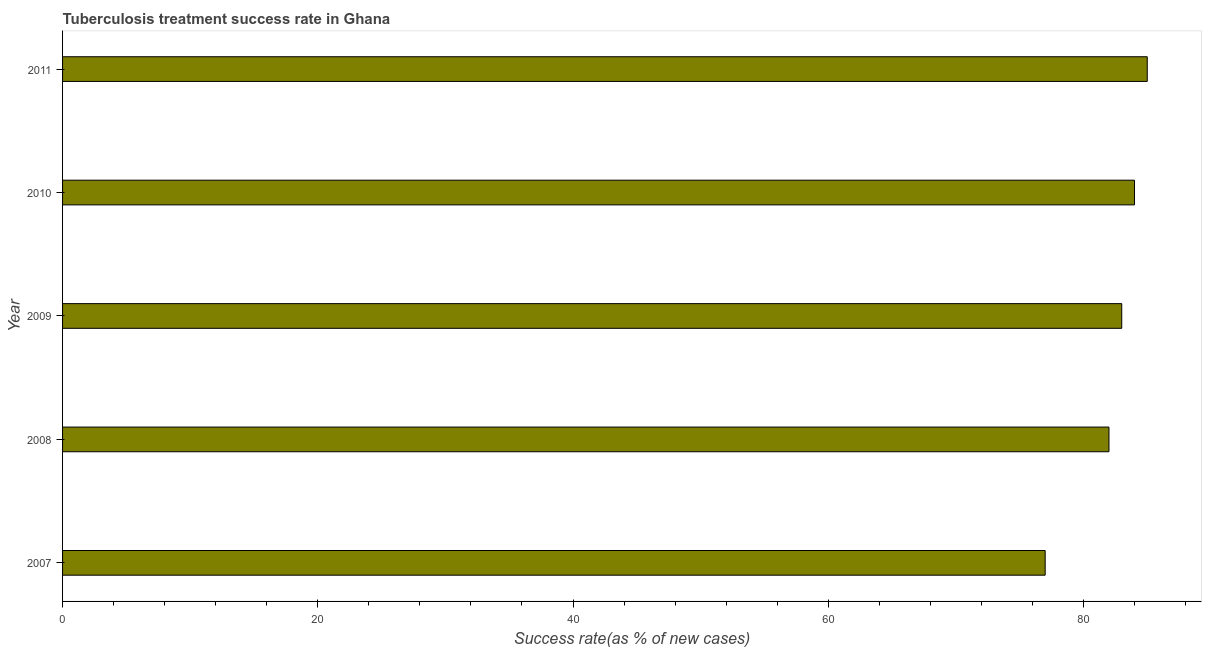Does the graph contain any zero values?
Offer a terse response. No. Does the graph contain grids?
Your answer should be very brief. No. What is the title of the graph?
Provide a short and direct response. Tuberculosis treatment success rate in Ghana. What is the label or title of the X-axis?
Offer a terse response. Success rate(as % of new cases). What is the tuberculosis treatment success rate in 2011?
Offer a very short reply. 85. In which year was the tuberculosis treatment success rate maximum?
Make the answer very short. 2011. What is the sum of the tuberculosis treatment success rate?
Give a very brief answer. 411. What is the difference between the tuberculosis treatment success rate in 2007 and 2009?
Your answer should be very brief. -6. What is the ratio of the tuberculosis treatment success rate in 2007 to that in 2010?
Give a very brief answer. 0.92. Is the difference between the tuberculosis treatment success rate in 2008 and 2011 greater than the difference between any two years?
Your answer should be compact. No. What is the difference between the highest and the second highest tuberculosis treatment success rate?
Your response must be concise. 1. Is the sum of the tuberculosis treatment success rate in 2008 and 2010 greater than the maximum tuberculosis treatment success rate across all years?
Ensure brevity in your answer.  Yes. In how many years, is the tuberculosis treatment success rate greater than the average tuberculosis treatment success rate taken over all years?
Give a very brief answer. 3. How many bars are there?
Offer a terse response. 5. Are all the bars in the graph horizontal?
Provide a short and direct response. Yes. How many years are there in the graph?
Provide a short and direct response. 5. What is the Success rate(as % of new cases) in 2007?
Offer a terse response. 77. What is the difference between the Success rate(as % of new cases) in 2007 and 2009?
Offer a terse response. -6. What is the difference between the Success rate(as % of new cases) in 2007 and 2011?
Your answer should be very brief. -8. What is the difference between the Success rate(as % of new cases) in 2009 and 2010?
Ensure brevity in your answer.  -1. What is the ratio of the Success rate(as % of new cases) in 2007 to that in 2008?
Provide a short and direct response. 0.94. What is the ratio of the Success rate(as % of new cases) in 2007 to that in 2009?
Your answer should be very brief. 0.93. What is the ratio of the Success rate(as % of new cases) in 2007 to that in 2010?
Give a very brief answer. 0.92. What is the ratio of the Success rate(as % of new cases) in 2007 to that in 2011?
Provide a succinct answer. 0.91. What is the ratio of the Success rate(as % of new cases) in 2009 to that in 2010?
Offer a terse response. 0.99. 